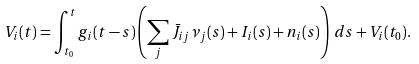Convert formula to latex. <formula><loc_0><loc_0><loc_500><loc_500>V _ { i } ( t ) = \int _ { t _ { 0 } } ^ { t } g _ { i } ( t - s ) \left ( \sum _ { j } \bar { J } _ { i j } \nu _ { j } ( s ) + I _ { i } ( s ) + n _ { i } ( s ) \right ) \, d s + V _ { i } ( t _ { 0 } ) .</formula> 